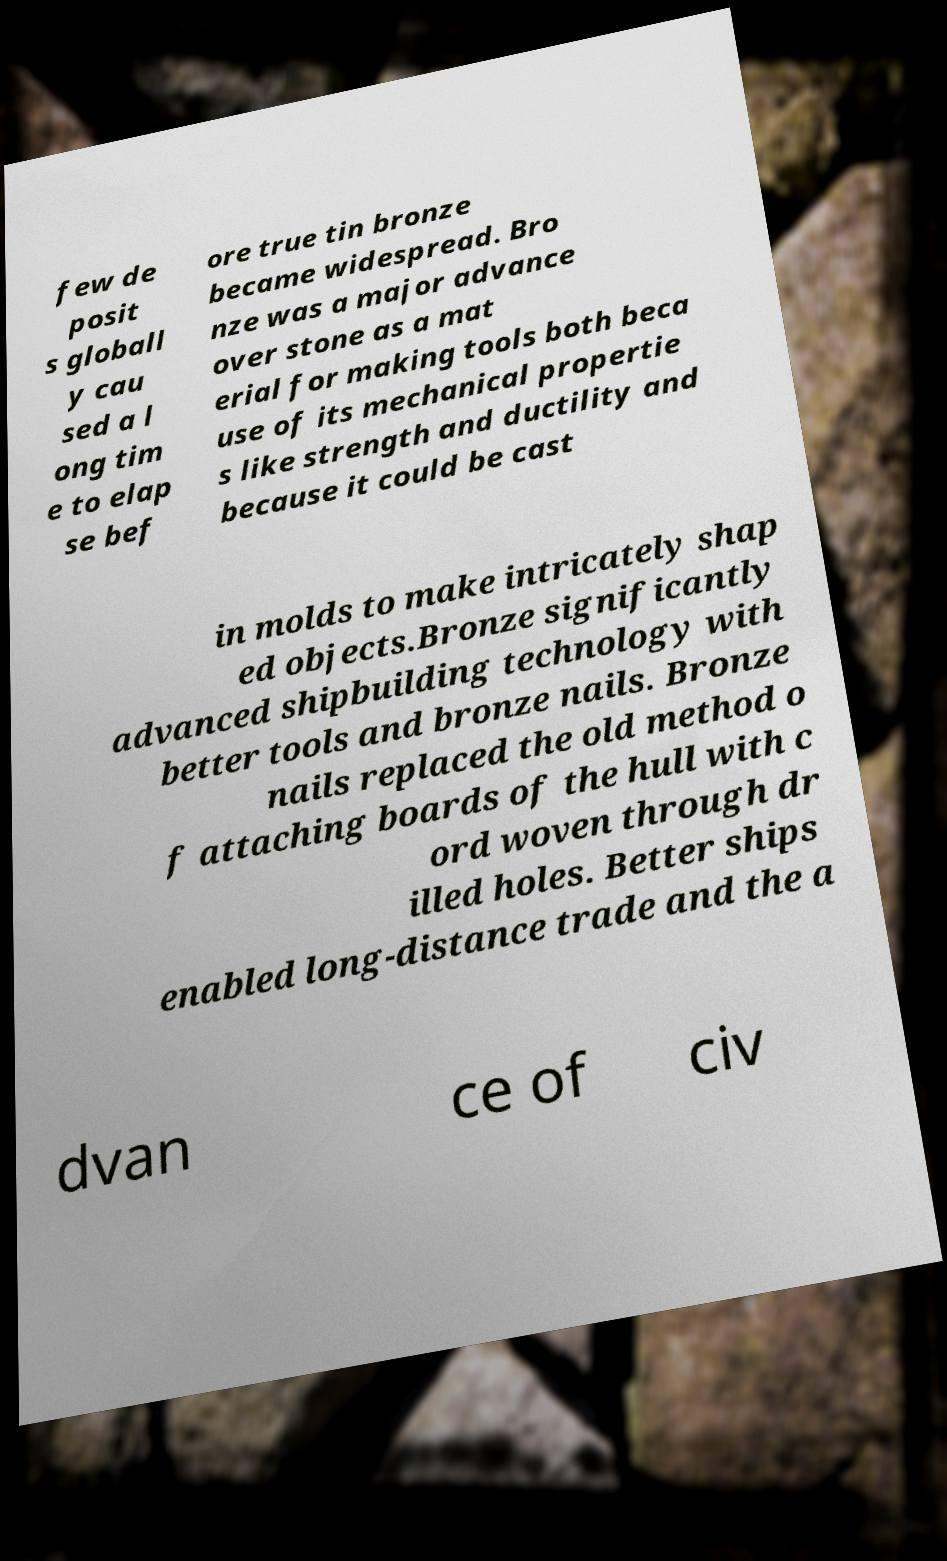Please read and relay the text visible in this image. What does it say? few de posit s globall y cau sed a l ong tim e to elap se bef ore true tin bronze became widespread. Bro nze was a major advance over stone as a mat erial for making tools both beca use of its mechanical propertie s like strength and ductility and because it could be cast in molds to make intricately shap ed objects.Bronze significantly advanced shipbuilding technology with better tools and bronze nails. Bronze nails replaced the old method o f attaching boards of the hull with c ord woven through dr illed holes. Better ships enabled long-distance trade and the a dvan ce of civ 